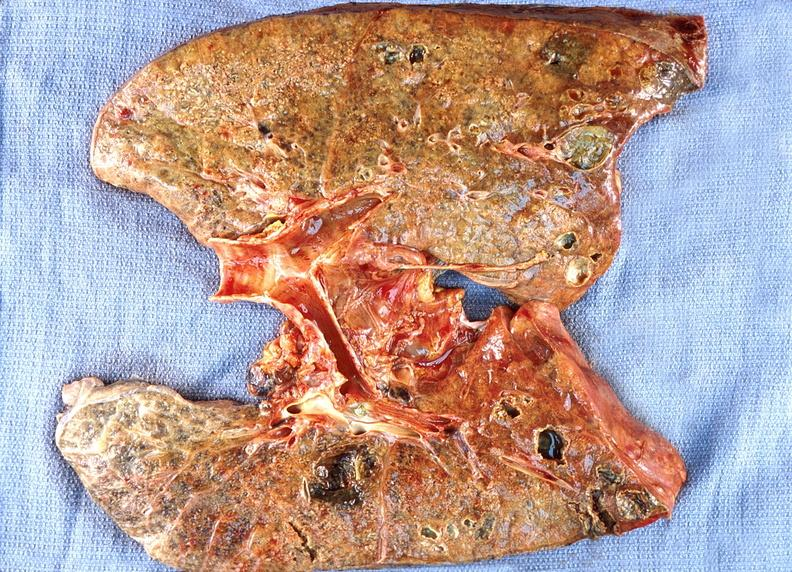s hyperplasia median bar present?
Answer the question using a single word or phrase. No 